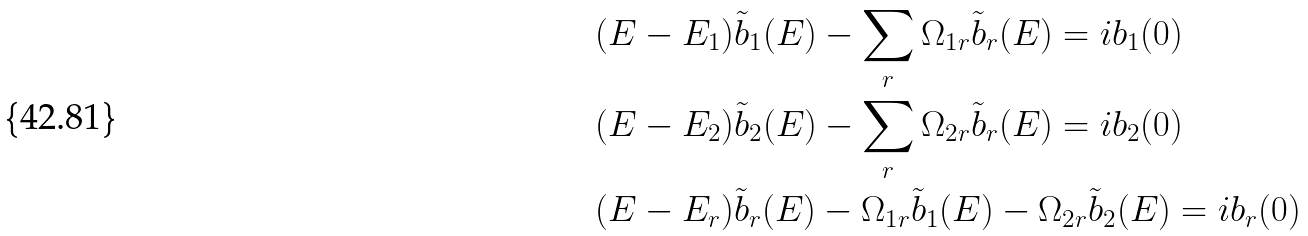<formula> <loc_0><loc_0><loc_500><loc_500>& ( E - E _ { 1 } ) \tilde { b } _ { 1 } ( E ) - \sum _ { r } \Omega _ { 1 r } \tilde { b } _ { r } ( E ) = i b _ { 1 } ( 0 ) \\ & ( E - E _ { 2 } ) \tilde { b } _ { 2 } ( E ) - \sum _ { r } \Omega _ { 2 r } \tilde { b } _ { r } ( E ) = i b _ { 2 } ( 0 ) \\ & ( E - E _ { r } ) \tilde { b } _ { r } ( E ) - \Omega _ { 1 r } \tilde { b } _ { 1 } ( E ) - \Omega _ { 2 r } \tilde { b } _ { 2 } ( E ) = i b _ { r } ( 0 )</formula> 